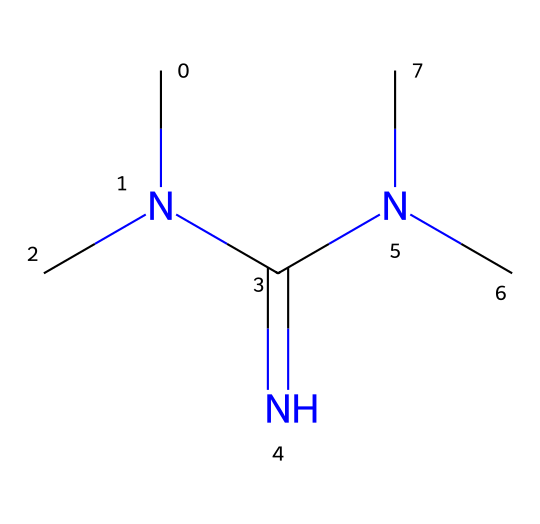What is the molecular formula of tetramethylguanidine? To determine the molecular formula, count the carbon (C), hydrogen (H), nitrogen (N), and oxygen (if applicable) atoms in the given SMILES structure. The breakdown shows 6 carbon atoms, 15 hydrogen atoms, and 4 nitrogen atoms. The molecular formula is C6H15N5.
Answer: C6H15N5 How many nitrogen atoms are present in tetramethylguanidine? The SMILES notation CN(C)C(=N)N(C)C shows there are four nitrogen atoms in the structure, both in the guanidine framework and the attachments.
Answer: 4 What type of functional groups are identified in tetramethylguanidine? Analyzing the SMILES, we see that tetramethylguanidine contains guanidine functional groups characterized by the presence of on nitrogen atom connected via a double bond and additional nitrogen atoms, indicating the basicity of the structure.
Answer: guanidine Why is tetramethylguanidine considered a superbase? Tetramethylguanidine is classified as a superbase due to its ability to deprotonate weak acids, which is linked to the high basicity of the nitrogen atoms in its structure. Its multiple nitrogen centers enhance proton acceptance and reactivity in various applications, particularly in organic synthesis and cleaning agents.
Answer: high basicity What is the significance of the methyl groups in tetramethylguanidine? The methyl groups serve to increase the steric hindrance around the nitrogen centers, which affects the chemical's reactivity and boosts its basic characteristics, thus enhancing its utility as a superbase in various chemical processes.
Answer: increase basicity 